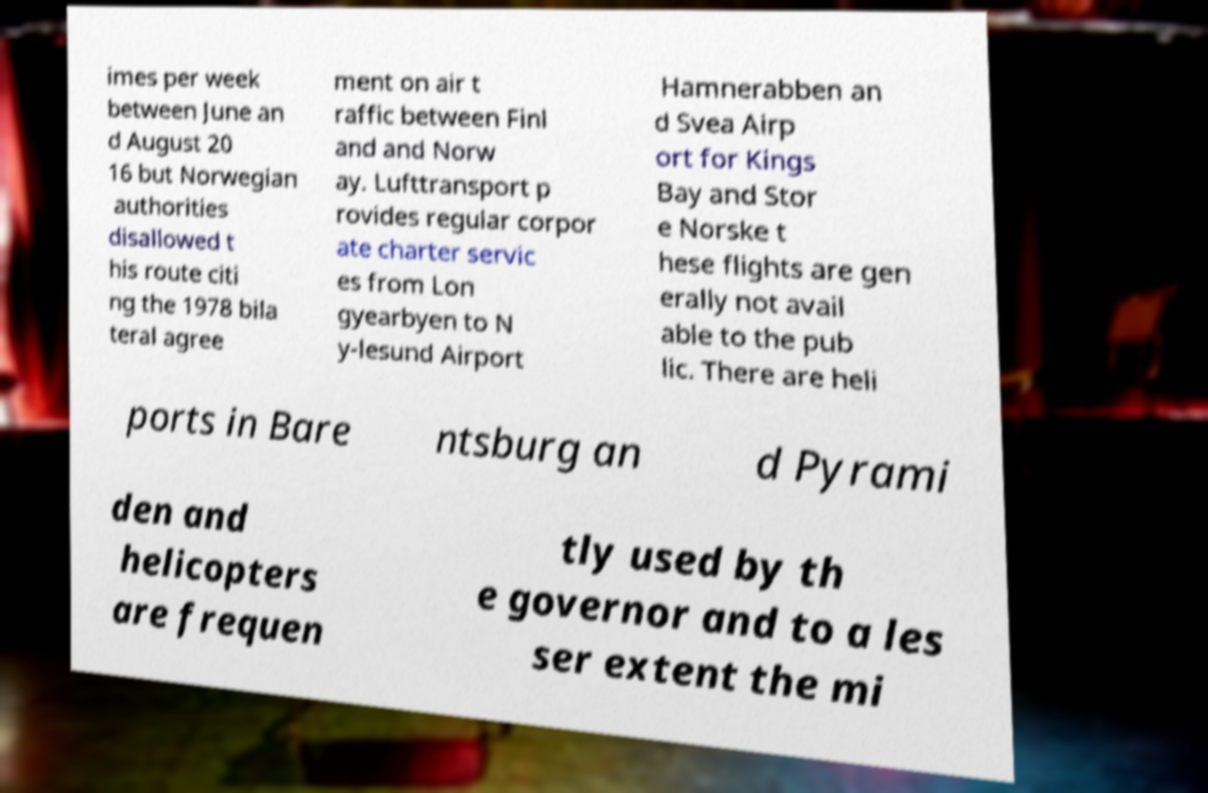Could you assist in decoding the text presented in this image and type it out clearly? imes per week between June an d August 20 16 but Norwegian authorities disallowed t his route citi ng the 1978 bila teral agree ment on air t raffic between Finl and and Norw ay. Lufttransport p rovides regular corpor ate charter servic es from Lon gyearbyen to N y-lesund Airport Hamnerabben an d Svea Airp ort for Kings Bay and Stor e Norske t hese flights are gen erally not avail able to the pub lic. There are heli ports in Bare ntsburg an d Pyrami den and helicopters are frequen tly used by th e governor and to a les ser extent the mi 